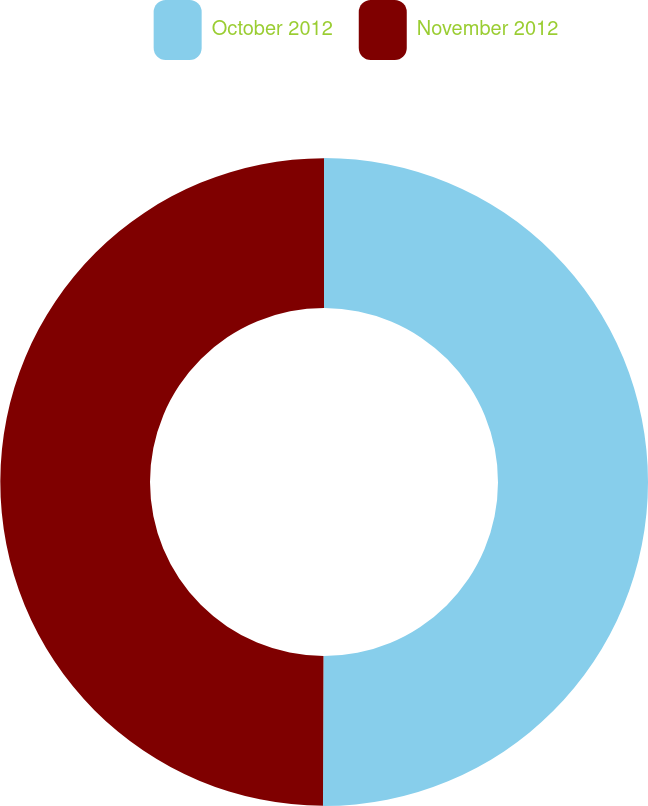<chart> <loc_0><loc_0><loc_500><loc_500><pie_chart><fcel>October 2012<fcel>November 2012<nl><fcel>50.05%<fcel>49.95%<nl></chart> 